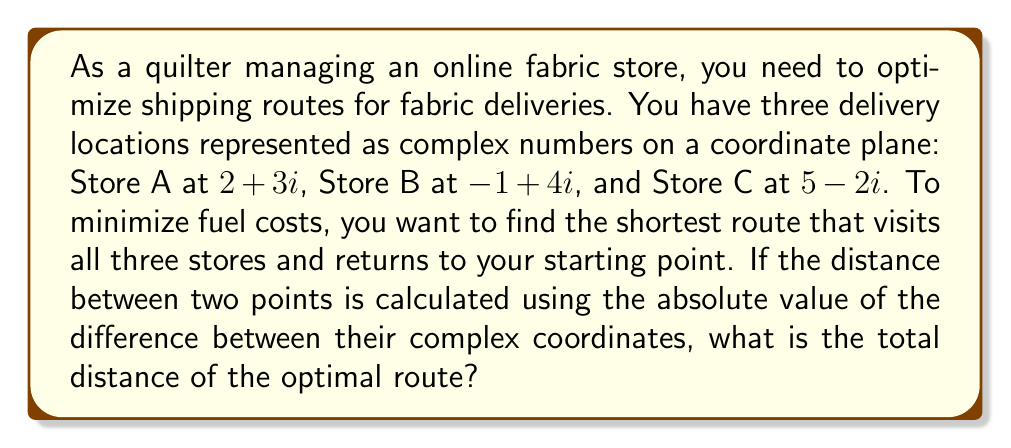Teach me how to tackle this problem. Let's approach this step-by-step:

1) First, we need to calculate the distances between each pair of stores:

   Distance(A to B) = $|(-1+4i) - (2+3i)| = |(-3+i)| = \sqrt{(-3)^2 + 1^2} = \sqrt{10}$
   Distance(A to C) = $|(5-2i) - (2+3i)| = |(3-5i)| = \sqrt{3^2 + (-5)^2} = \sqrt{34}$
   Distance(B to C) = $|(5-2i) - (-1+4i)| = |(6-6i)| = \sqrt{6^2 + (-6)^2} = 6\sqrt{2}$

2) Now, we need to find the shortest route that visits all three stores and returns to the starting point. There are three possible routes:

   Route 1: A → B → C → A
   Route 2: A → C → B → A
   Route 3: B → A → C → B (starting from B)

3) Let's calculate the total distance for each route:

   Route 1: $\sqrt{10} + 6\sqrt{2} + \sqrt{34}$
   Route 2: $\sqrt{34} + 6\sqrt{2} + \sqrt{10}$
   Route 3: $\sqrt{10} + \sqrt{34} + 6\sqrt{2}$

4) We can see that all routes have the same total distance. This is because the problem forms a triangle, and the order of visiting the points doesn't change the total distance.

5) Therefore, the optimal route distance is:

   $\sqrt{10} + 6\sqrt{2} + \sqrt{34}$

6) To simplify this, we can leave it in surd form:

   $\sqrt{10} + 6\sqrt{2} + \sqrt{34}$
Answer: The total distance of the optimal route is $\sqrt{10} + 6\sqrt{2} + \sqrt{34}$. 